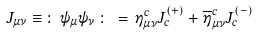<formula> <loc_0><loc_0><loc_500><loc_500>J _ { \mu \nu } \equiv \, \colon \, \psi _ { \mu } \psi _ { \nu } \, \colon \, = \, \eta ^ { c } _ { \mu \nu } J _ { c } ^ { ( + ) } + \overline { \eta } ^ { c } _ { \mu \nu } J _ { c } ^ { ( - ) }</formula> 